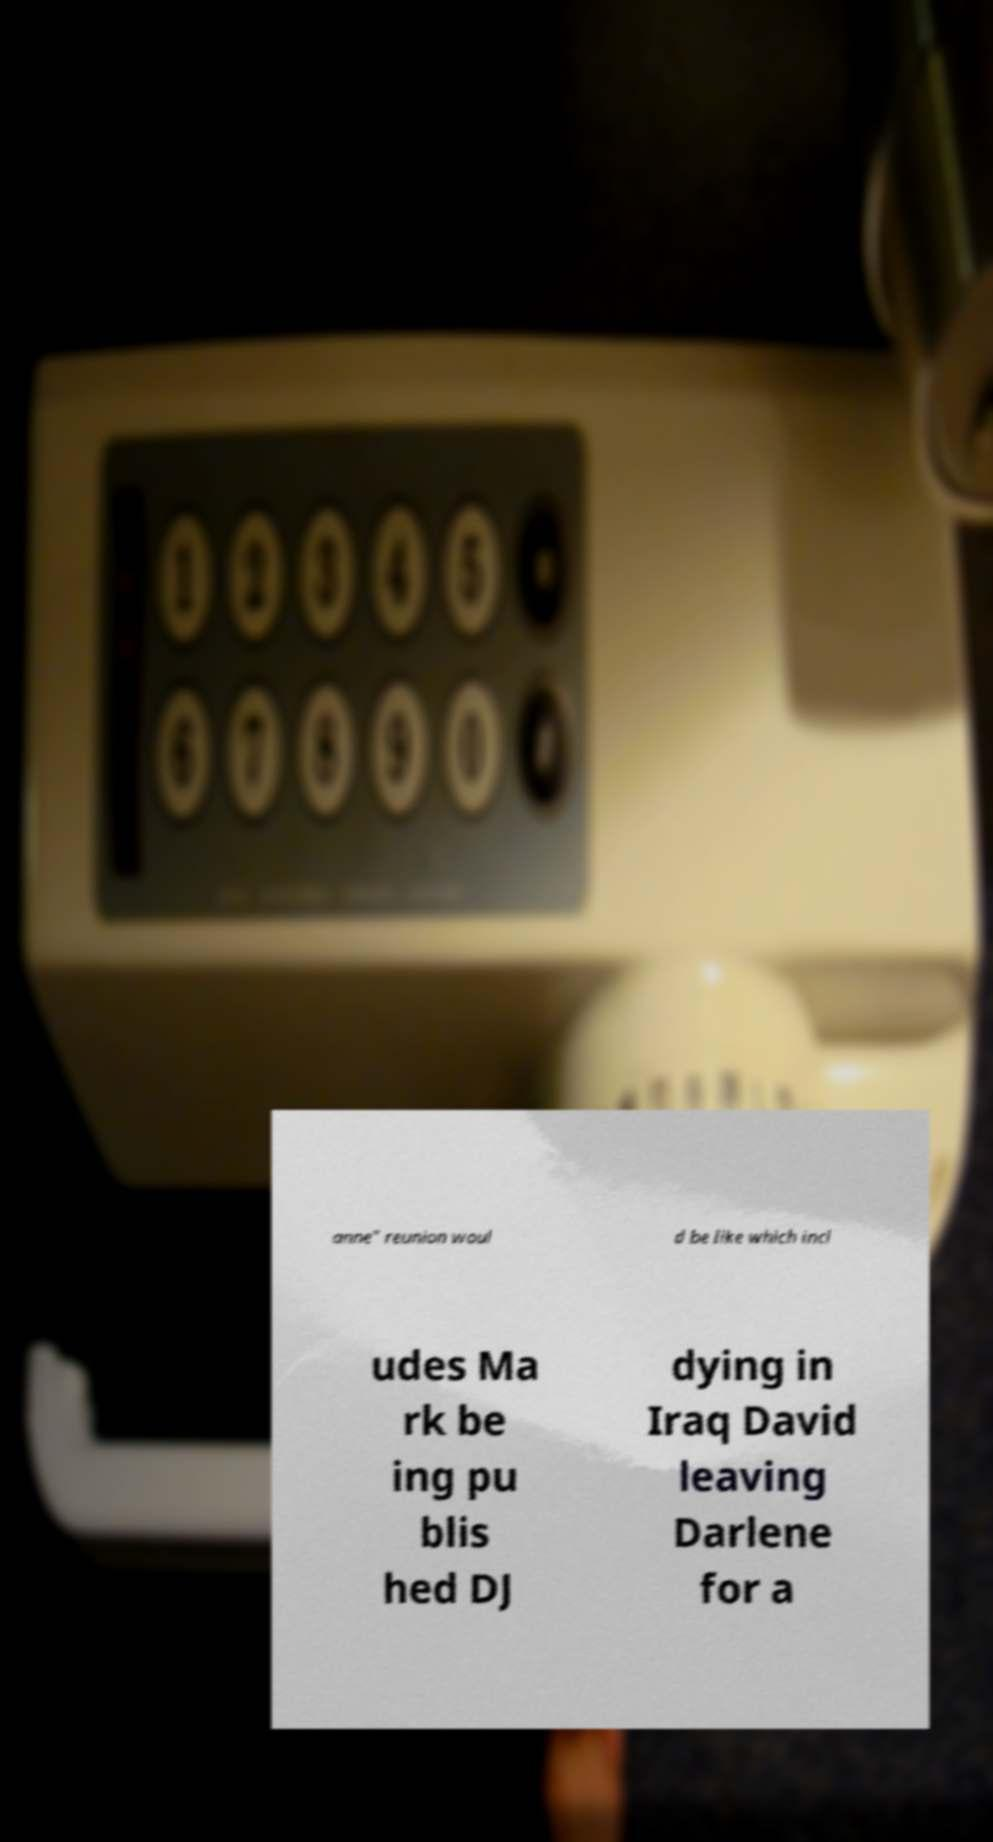Could you extract and type out the text from this image? anne" reunion woul d be like which incl udes Ma rk be ing pu blis hed DJ dying in Iraq David leaving Darlene for a 